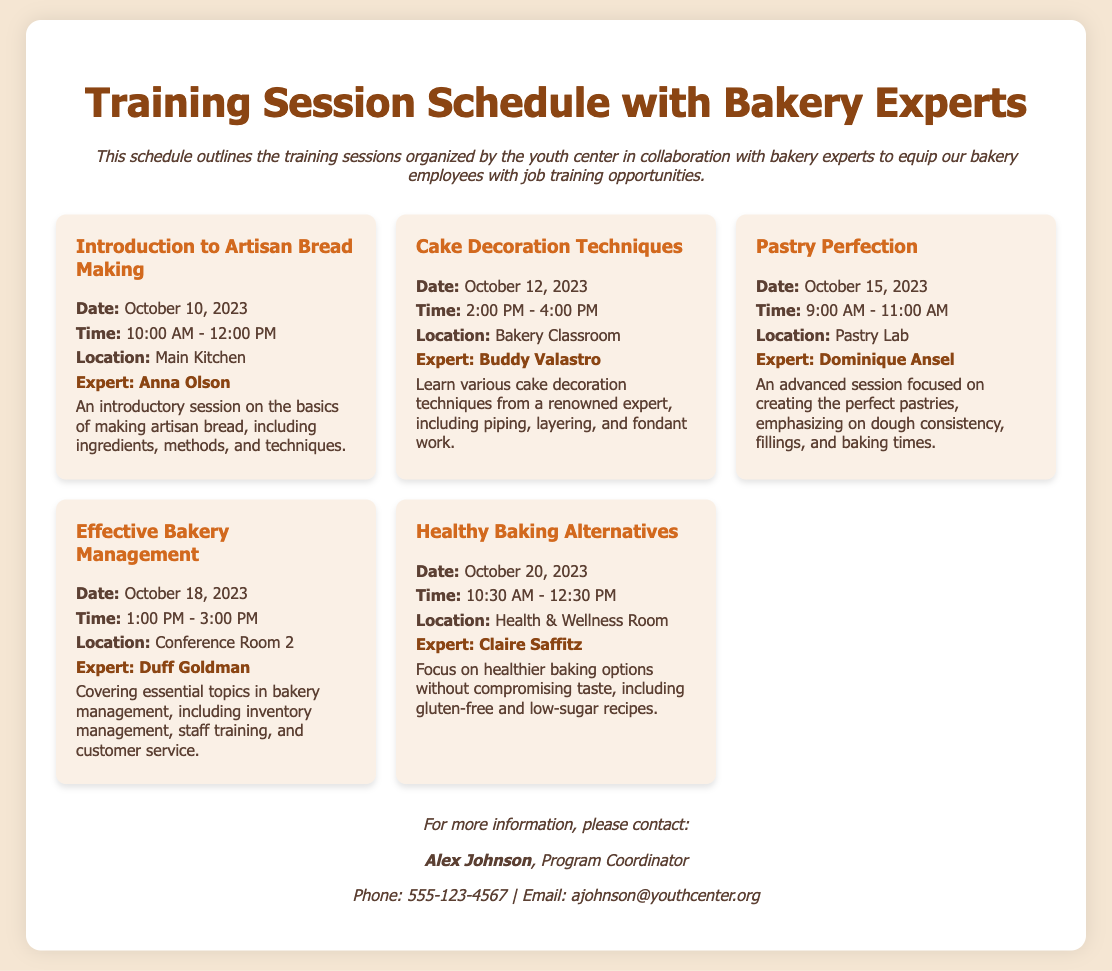What is the date of the first training session? The first training session is titled "Introduction to Artisan Bread Making," which is scheduled for October 10, 2023.
Answer: October 10, 2023 Who is the expert for the session on cake decoration? The expert for the session on cake decoration techniques is Buddy Valastro.
Answer: Buddy Valastro What time does the Healthy Baking Alternatives session start? The Healthy Baking Alternatives session starts at 10:30 AM on October 20, 2023.
Answer: 10:30 AM How many sessions are scheduled in total? There are five training sessions listed in the schedule document.
Answer: Five What is the location for the session on Effective Bakery Management? The session on Effective Bakery Management is located in Conference Room 2.
Answer: Conference Room 2 